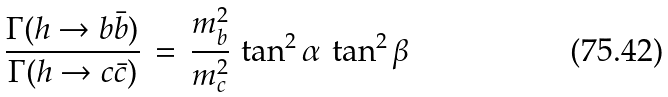Convert formula to latex. <formula><loc_0><loc_0><loc_500><loc_500>\frac { \Gamma ( h \rightarrow b \bar { b } ) } { \Gamma ( h \rightarrow c \bar { c } ) } \, = \, \frac { m _ { b } ^ { 2 } } { m _ { c } ^ { 2 } } \, \tan ^ { 2 } \alpha \, \tan ^ { 2 } \beta</formula> 